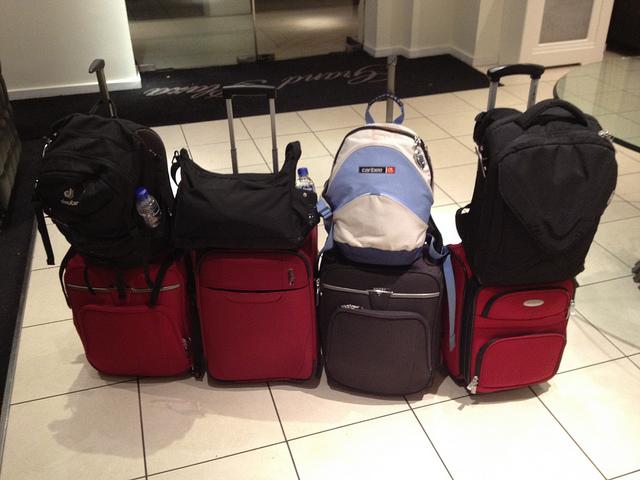How many red bags are in the picture?
Keep it brief. 3. Is the floor tiled?
Be succinct. Yes. What recent decade was this color of suitcase popular?
Give a very brief answer. 2000s. Is there a water bottle in one of the backpacks?
Be succinct. Yes. 